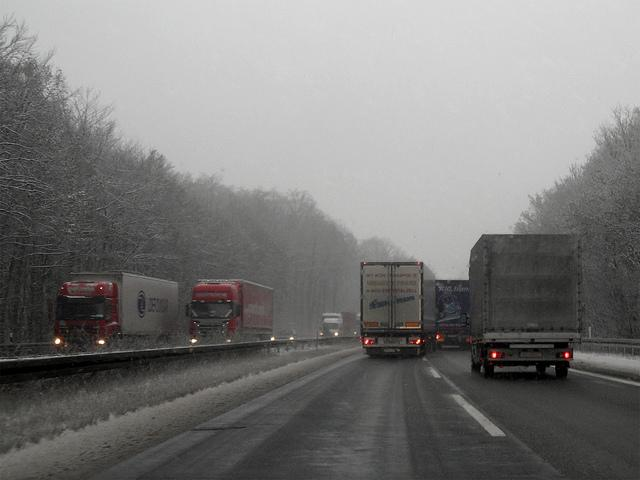What is blowing in the wind? Please explain your reasoning. snow. It is snowing and the snow is being blown in the wind. 